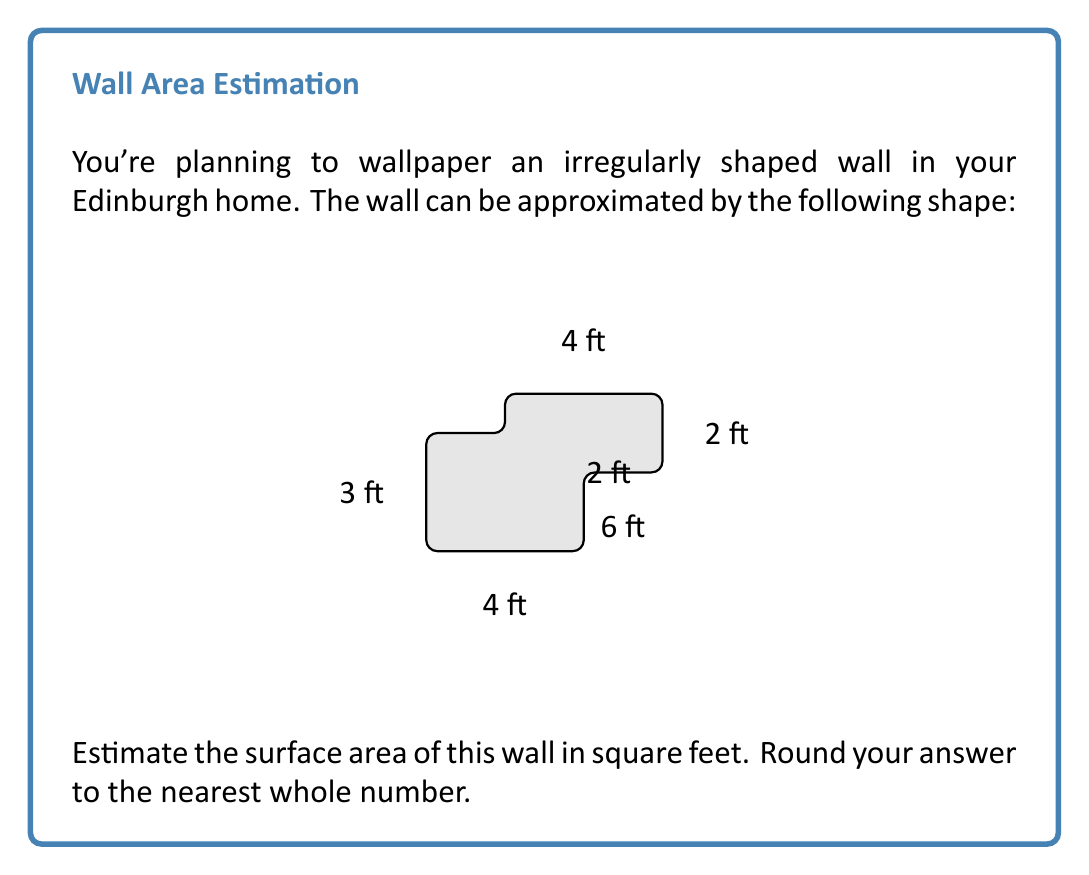What is the answer to this math problem? To estimate the surface area of this irregularly shaped wall, we'll break it down into rectangles and calculate their areas:

1. Main rectangle:
   $$ A_1 = 4 \text{ ft} \times 3 \text{ ft} = 12 \text{ sq ft} $$

2. Upper right rectangle:
   $$ A_2 = 2 \text{ ft} \times 1 \text{ ft} = 2 \text{ sq ft} $$

3. Upper left rectangle:
   $$ A_3 = 2 \text{ ft} \times 1 \text{ ft} = 2 \text{ sq ft} $$

4. Lower right rectangle:
   $$ A_4 = 2 \text{ ft} \times 2 \text{ ft} = 4 \text{ sq ft} $$

Now, we sum up all these areas:

$$ A_{\text{total}} = A_1 + A_2 + A_3 + A_4 $$
$$ A_{\text{total}} = 12 + 2 + 2 + 4 = 20 \text{ sq ft} $$

The estimated surface area is 20 square feet, which is already a whole number, so no rounding is necessary.
Answer: 20 sq ft 